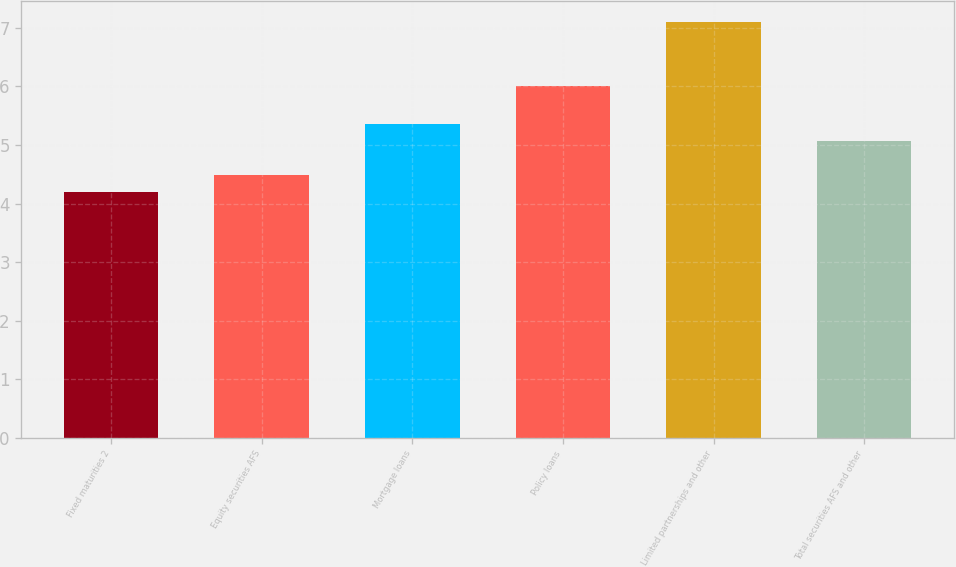Convert chart. <chart><loc_0><loc_0><loc_500><loc_500><bar_chart><fcel>Fixed maturities 2<fcel>Equity securities AFS<fcel>Mortgage loans<fcel>Policy loans<fcel>Limited partnerships and other<fcel>Total securities AFS and other<nl><fcel>4.2<fcel>4.49<fcel>5.36<fcel>6<fcel>7.1<fcel>5.07<nl></chart> 